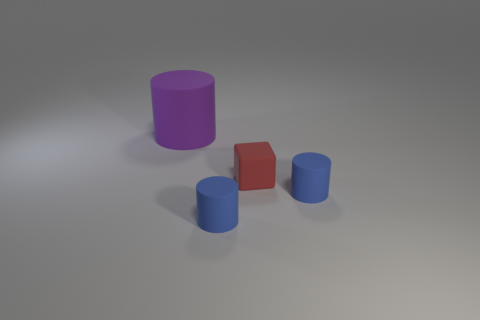Subtract all purple matte cylinders. How many cylinders are left? 2 Subtract all purple cylinders. How many cylinders are left? 2 Subtract 1 blocks. How many blocks are left? 0 Subtract all cubes. How many objects are left? 3 Subtract 0 yellow cylinders. How many objects are left? 4 Subtract all blue cylinders. Subtract all red spheres. How many cylinders are left? 1 Subtract all brown cylinders. How many cyan blocks are left? 0 Subtract all small cylinders. Subtract all big purple cylinders. How many objects are left? 1 Add 4 small rubber cylinders. How many small rubber cylinders are left? 6 Add 1 cyan shiny blocks. How many cyan shiny blocks exist? 1 